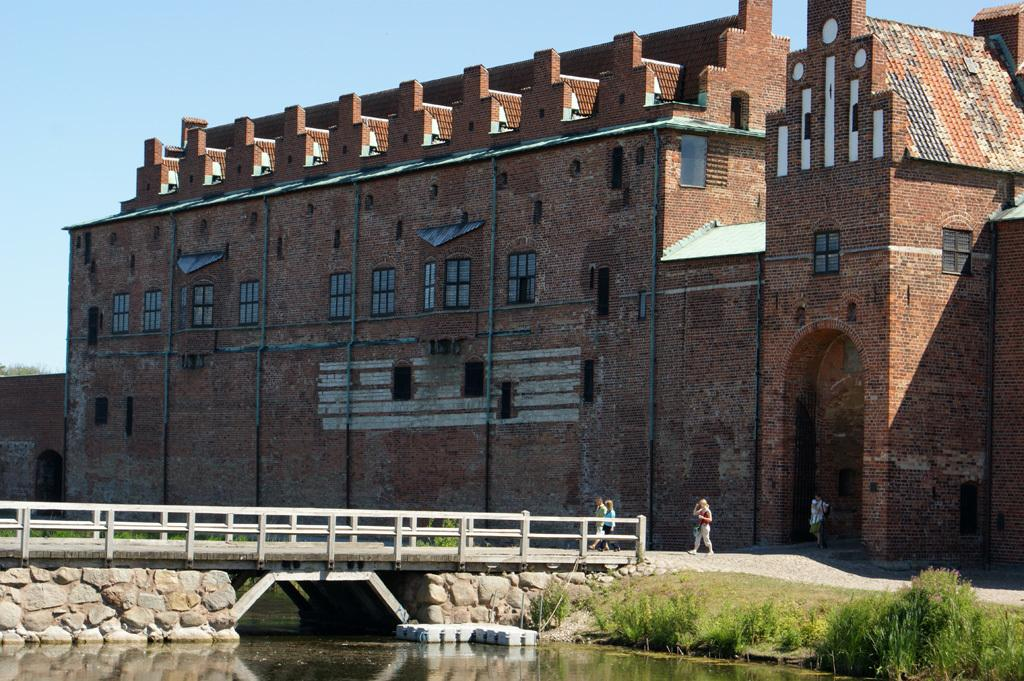What are the persons in the image doing? The persons in the image are walking. What structure can be seen in the image? There is a bridge in the image. What can be seen in the background of the image? There is a building and grass in the background of the image. What is the color of the building in the image? The building is brown in color. What is the color of the sky in the image? The sky is blue in color. What is the color of the grass in the image? The grass is green in color. What type of orange can be seen on the stove in the image? There is no orange or stove present in the image. What emotion can be seen on the faces of the persons in the image? The provided facts do not mention any emotions or facial expressions of the persons in the image. 